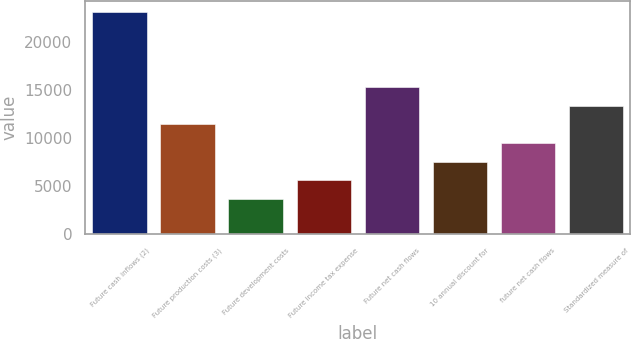Convert chart. <chart><loc_0><loc_0><loc_500><loc_500><bar_chart><fcel>Future cash inflows (2)<fcel>Future production costs (3)<fcel>Future development costs<fcel>Future income tax expense<fcel>Future net cash flows<fcel>10 annual discount for<fcel>future net cash flows<fcel>Standardized measure of<nl><fcel>23065<fcel>11417.8<fcel>3653<fcel>5594.2<fcel>15300.2<fcel>7535.4<fcel>9476.6<fcel>13359<nl></chart> 